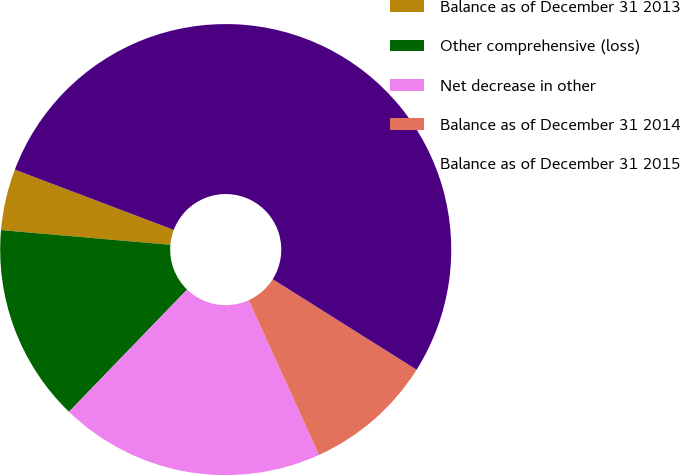<chart> <loc_0><loc_0><loc_500><loc_500><pie_chart><fcel>Balance as of December 31 2013<fcel>Other comprehensive (loss)<fcel>Net decrease in other<fcel>Balance as of December 31 2014<fcel>Balance as of December 31 2015<nl><fcel>4.39%<fcel>14.15%<fcel>19.02%<fcel>9.27%<fcel>53.17%<nl></chart> 